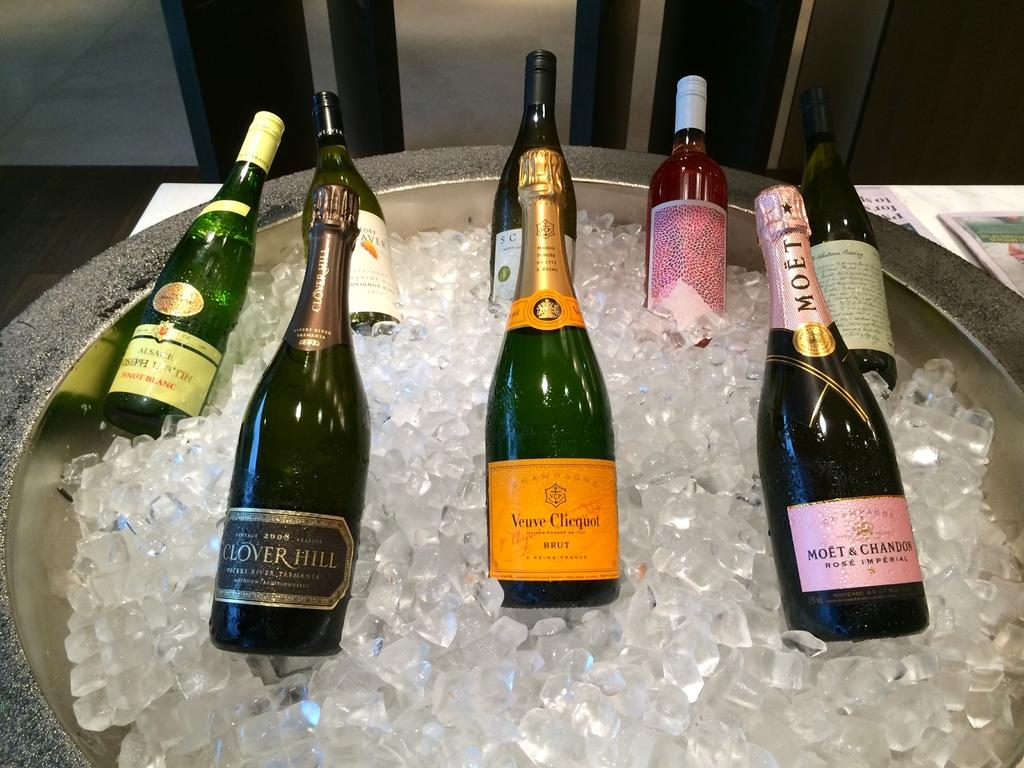<image>
Describe the image concisely. the word Veuve that is on a bottle 